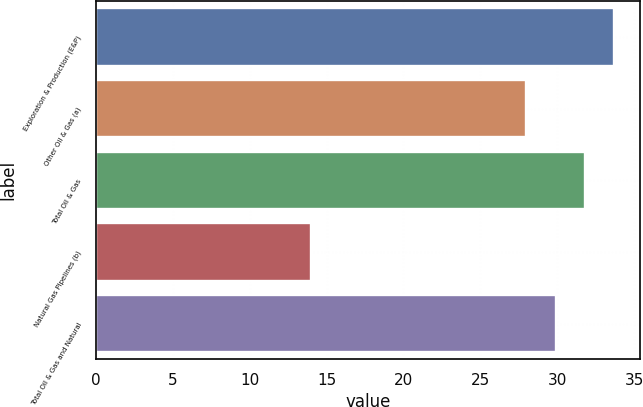Convert chart. <chart><loc_0><loc_0><loc_500><loc_500><bar_chart><fcel>Exploration & Production (E&P)<fcel>Other Oil & Gas (a)<fcel>Total Oil & Gas<fcel>Natural Gas Pipelines (b)<fcel>Total Oil & Gas and Natural<nl><fcel>33.7<fcel>28<fcel>31.8<fcel>14<fcel>29.9<nl></chart> 